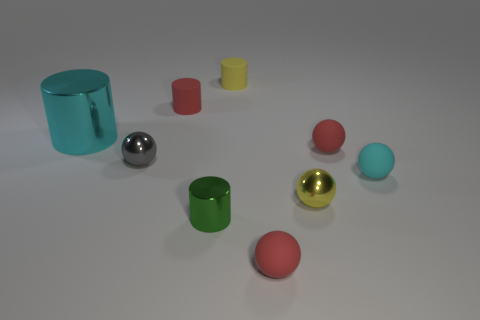Subtract all yellow metallic balls. How many balls are left? 4 Add 1 big cyan shiny cylinders. How many objects exist? 10 Subtract all cylinders. How many objects are left? 5 Subtract 2 spheres. How many spheres are left? 3 Add 8 tiny gray metallic objects. How many tiny gray metallic objects exist? 9 Subtract all green cylinders. How many cylinders are left? 3 Subtract 1 red spheres. How many objects are left? 8 Subtract all yellow spheres. Subtract all gray cubes. How many spheres are left? 4 Subtract all cyan spheres. How many cyan cylinders are left? 1 Subtract all yellow metal spheres. Subtract all tiny yellow spheres. How many objects are left? 7 